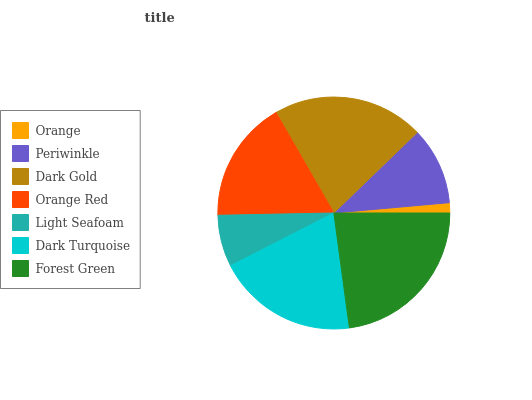Is Orange the minimum?
Answer yes or no. Yes. Is Forest Green the maximum?
Answer yes or no. Yes. Is Periwinkle the minimum?
Answer yes or no. No. Is Periwinkle the maximum?
Answer yes or no. No. Is Periwinkle greater than Orange?
Answer yes or no. Yes. Is Orange less than Periwinkle?
Answer yes or no. Yes. Is Orange greater than Periwinkle?
Answer yes or no. No. Is Periwinkle less than Orange?
Answer yes or no. No. Is Orange Red the high median?
Answer yes or no. Yes. Is Orange Red the low median?
Answer yes or no. Yes. Is Dark Turquoise the high median?
Answer yes or no. No. Is Dark Gold the low median?
Answer yes or no. No. 